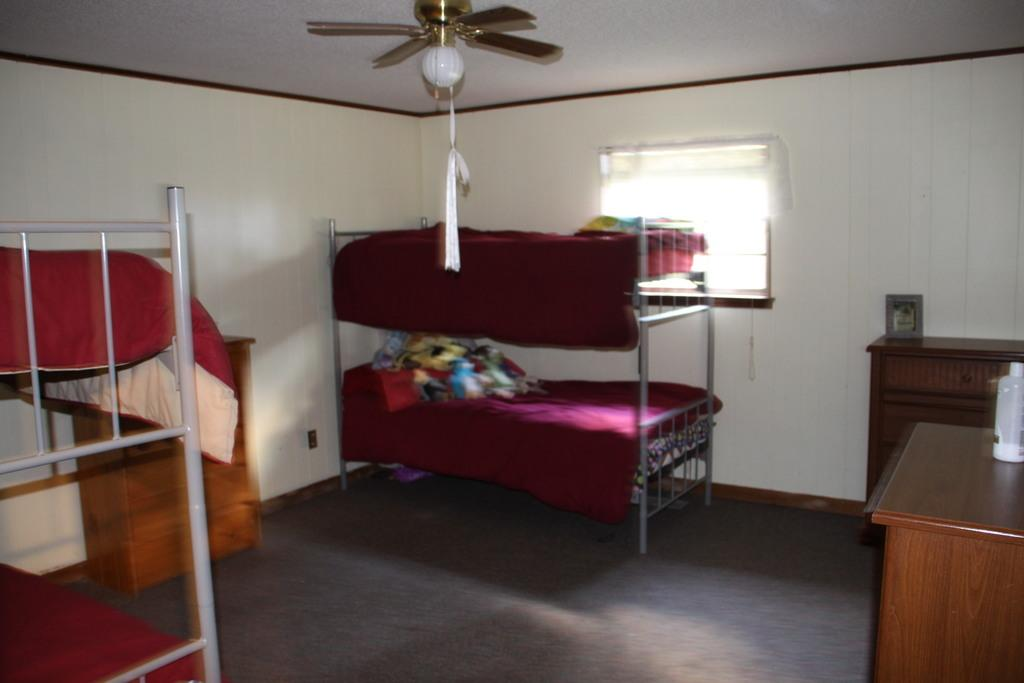What type of furniture is present in the image? There are beds and tables in the image. What is placed on the tables? There are two things on the tables. What is used for air circulation in the image? There is a fan in the image. What type of structure is visible in the image? There is a wall in the image. What allows natural light and air to enter the room in the image? There is a window in the image. What type of ornament is hanging from the ceiling in the image? There is no ornament hanging from the ceiling in the image. Are there any police officers visible in the image? There is no mention of police officers in the image. How many houses are visible in the image? There is only one house visible in the image, as the image shows a room within a house. 